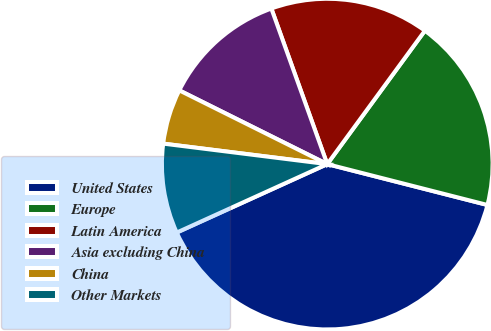Convert chart. <chart><loc_0><loc_0><loc_500><loc_500><pie_chart><fcel>United States<fcel>Europe<fcel>Latin America<fcel>Asia excluding China<fcel>China<fcel>Other Markets<nl><fcel>39.23%<fcel>18.92%<fcel>15.54%<fcel>12.15%<fcel>5.38%<fcel>8.77%<nl></chart> 